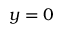<formula> <loc_0><loc_0><loc_500><loc_500>y = 0</formula> 